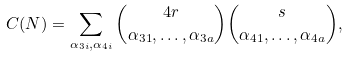<formula> <loc_0><loc_0><loc_500><loc_500>C ( N ) = \sum _ { \alpha _ { 3 i } , \alpha _ { 4 i } } \binom { 4 r } { \alpha _ { 3 1 } , \dots , \alpha _ { 3 a } } \binom { s } { \alpha _ { 4 1 } , \dots , \alpha _ { 4 a } } ,</formula> 